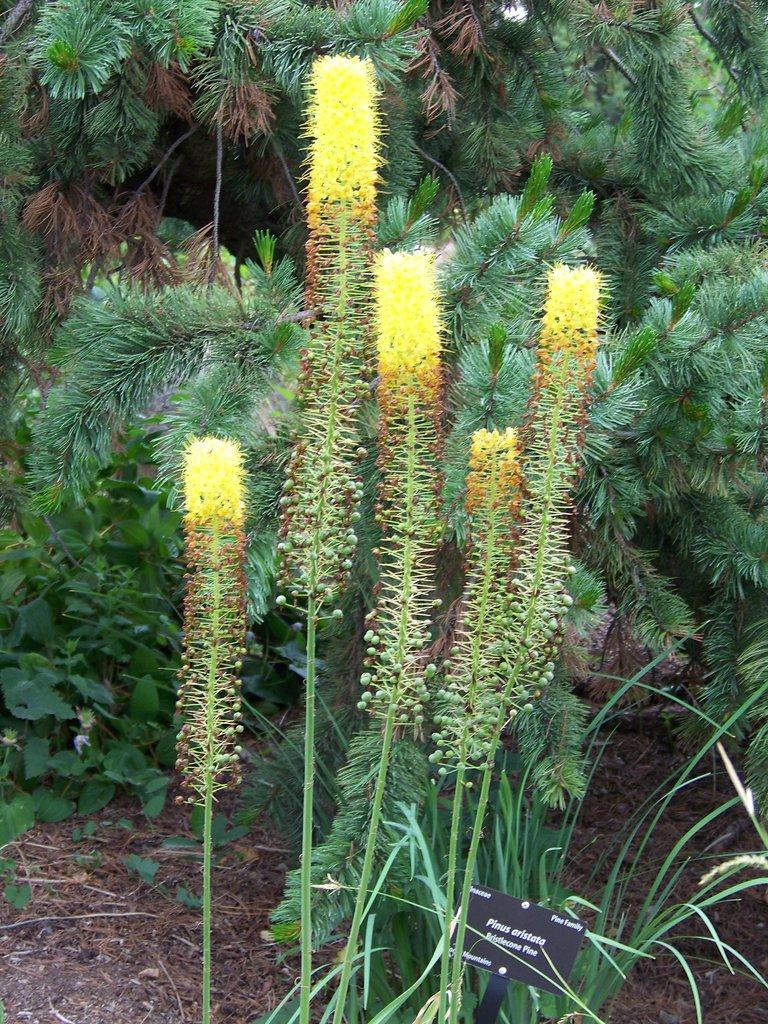What type of living organisms can be seen in the image? Plants can be seen in the image. What else is present in the image besides the plants? There is a card with text in the image. What type of grass is being used to make the kettle in the image? There is no grass or kettle present in the image. 